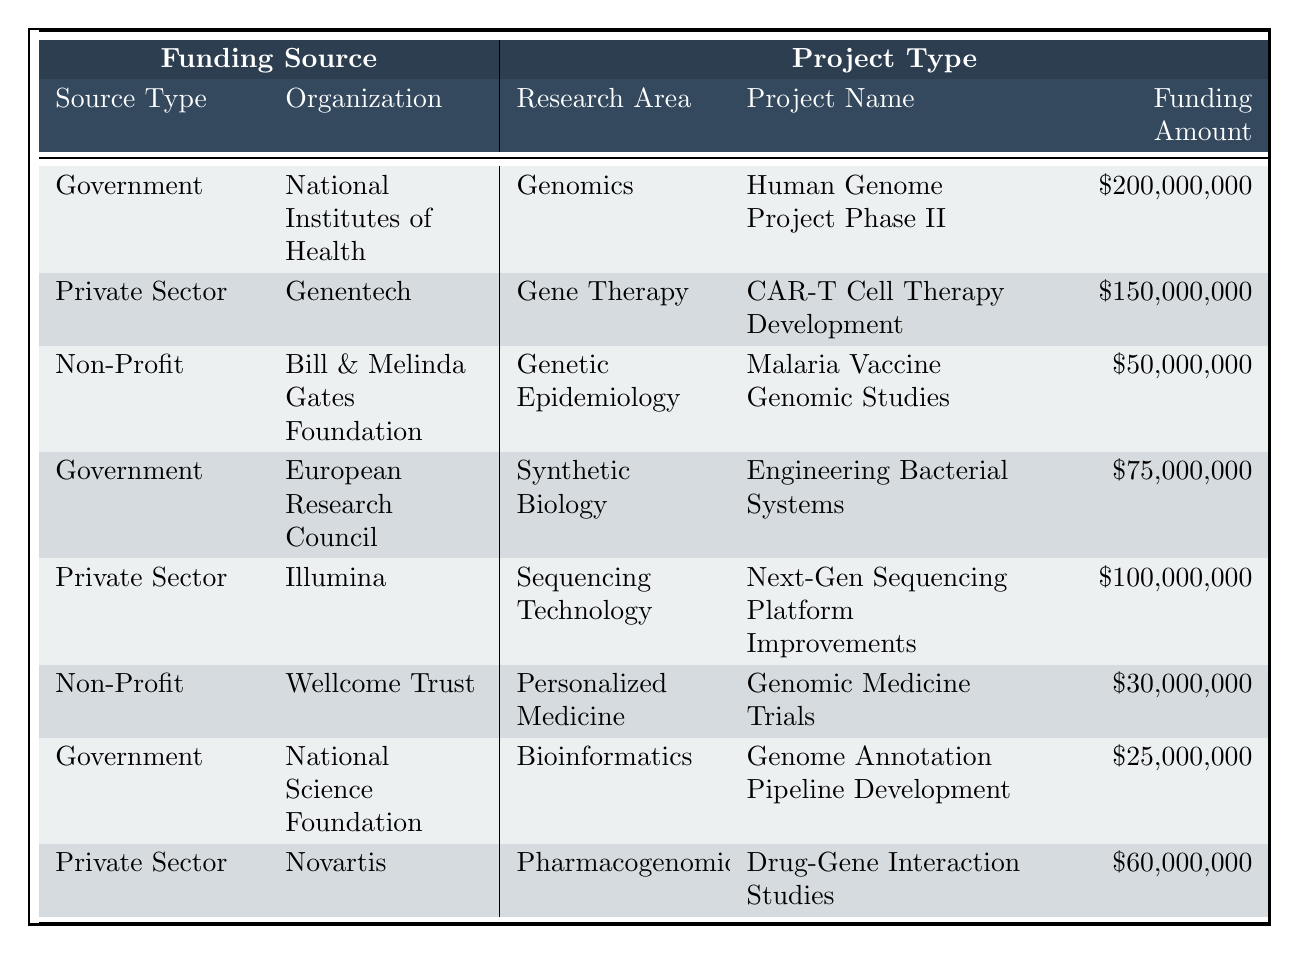What is the total funding amount from private sector organizations? The private sector funding amounts listed are $150,000,000 from Genentech, $100,000,000 from Illumina, and $60,000,000 from Novartis. Adding these amounts: 150 + 100 + 60 = 310 million dollars.
Answer: $310,000,000 Which organization received the least funding for their project? The funding amounts for each project are $200,000,000, $150,000,000, $50,000,000, $75,000,000, $100,000,000, $30,000,000, $25,000,000, and $60,000,000. The least among these is $25,000,000. This amount is designated to the National Science Foundation.
Answer: National Science Foundation Is there any project funded by a non-profit organization that focuses on pharmacogenomics? The non-profit organizations in the table include the Bill & Melinda Gates Foundation and the Wellcome Trust. Their projects focus on Genetic Epidemiology (Malaria Vaccine Genomic Studies) and Personalized Medicine (Genomic Medicine Trials), respectively. Neither project is related to pharmacogenomics.
Answer: No What is the average funding amount for government-funded projects? There are three government-funded projects: $200,000,000, $75,000,000, and $25,000,000. First, sum these amounts: 200 + 75 + 25 = 300 million dollars. Next, divide the total funding by the number of projects (3): 300 / 3 = 100 million dollars.
Answer: $100,000,000 What is the organization with the highest single project funding, and how much is it? The highest funding amounts in the table are $200,000,000 from the National Institutes of Health for the Human Genome Project Phase II. By comparison, all other funding amounts are lower than this.
Answer: National Institutes of Health, $200,000,000 How many projects were funded by the government? The table lists three projects that are funded by government sources: the Human Genome Project Phase II, Engineering Bacterial Systems, and Genome Annotation Pipeline Development. Therefore, the count of government projects is three.
Answer: 3 Which project involved the lowest overall funding, and what was the amount? The funding amounts in the table go as follows: $200,000,000, $150,000,000, $50,000,000, $75,000,000, $100,000,000, $30,000,000, $25,000,000, and $60,000,000. The lowest amount is $25,000,000, which is for the Genome Annotation Pipeline Development.
Answer: Genome Annotation Pipeline Development, $25,000,000 Are more funds allocated to research areas related to genomics than to gene therapy? The funding for genomics (Human Genome Project Phase II) is $200,000,000, and for gene therapy (CAR-T Cell Therapy Development) it is $150,000,000. Since $200,000,000 is greater than $150,000,000, more funds are allocated to genomics.
Answer: Yes What percentage of the total funding is allocated to personalized medicine projects? The total funding amounts are: $200,000,000 + $150,000,000 + $50,000,000 + $75,000,000 + $100,000,000 + $30,000,000 + $25,000,000 + $60,000,000 = $690,000,000. The funding for personalized medicine (Genomic Medicine Trials) is $30,000,000. To find the percentage, divide $30,000,000 by the total funding and multiply by 100: (30 / 690) * 100 ≈ 4.35%.
Answer: Approximately 4.35% If we remove the government funding from total funding, what remains? The total funding is $690,000,000 and the total funding for government projects is $200,000,000 + $75,000,000 + $25,000,000 = $300,000,000. Subtract this from the total: $690,000,000 - $300,000,000 = $390,000,000.
Answer: $390,000,000 